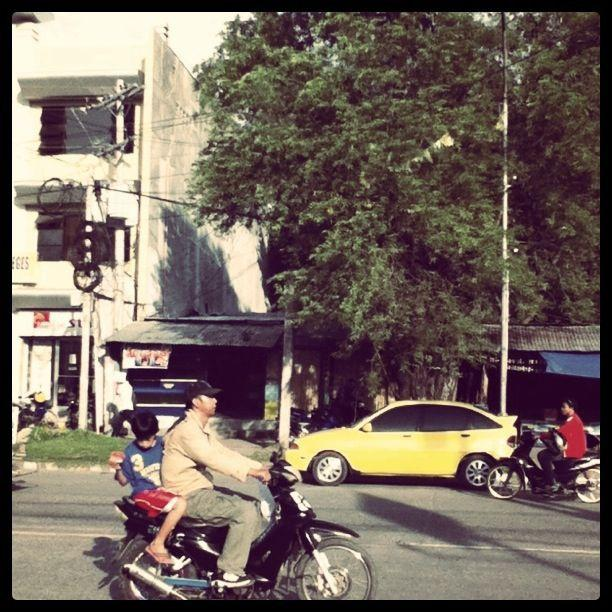Which mode of transportation shown here is most economical?

Choices:
A) truck
B) semi
C) car
D) motor cycle motor cycle 